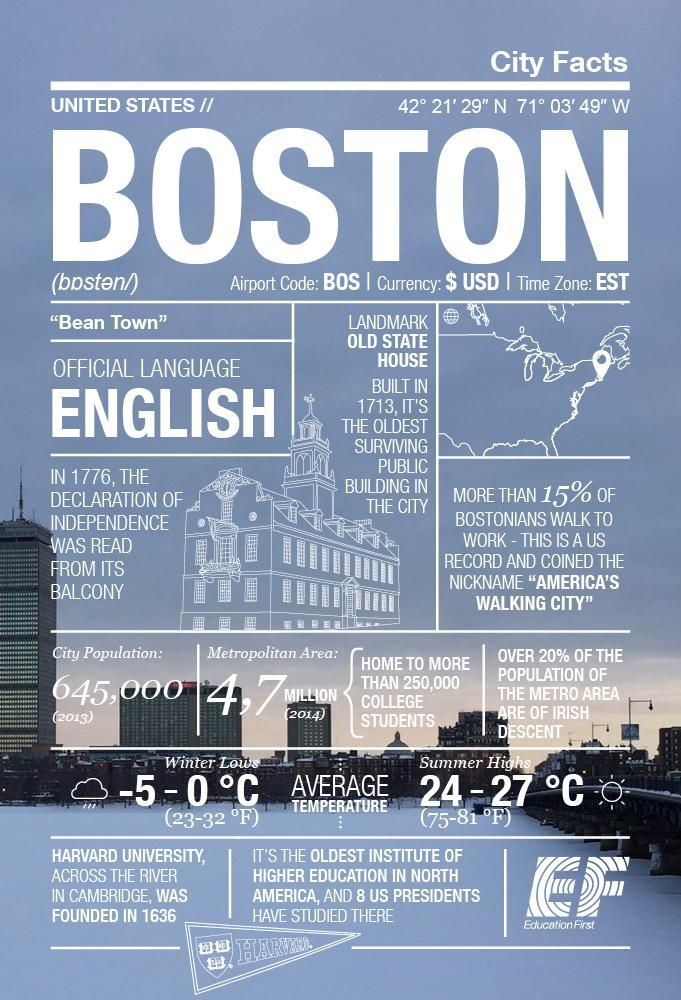What is range of temperature in summer in Boston , 23 - 32 F, 50 - 65 F,  or 75 - 81 F?
Answer the question with a short phrase. 75 - 81 F 